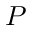<formula> <loc_0><loc_0><loc_500><loc_500>P</formula> 